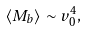Convert formula to latex. <formula><loc_0><loc_0><loc_500><loc_500>\langle M _ { b } \rangle \sim v _ { 0 } ^ { 4 } ,</formula> 